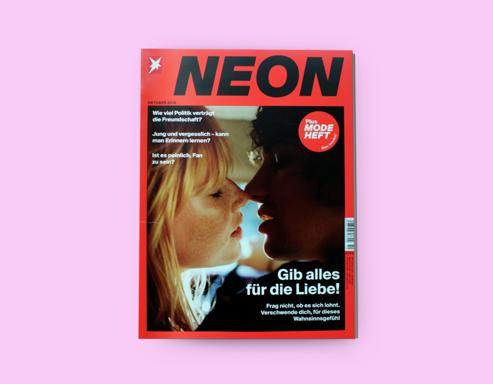What is the title of the magazine cover?
 The magazine cover is titled "NEON." What is the message or theme emphasized on the magazine cover? The message or theme emphasized on the magazine cover is "Gib alles für die Liebe," which translates to "Give everything for love." 